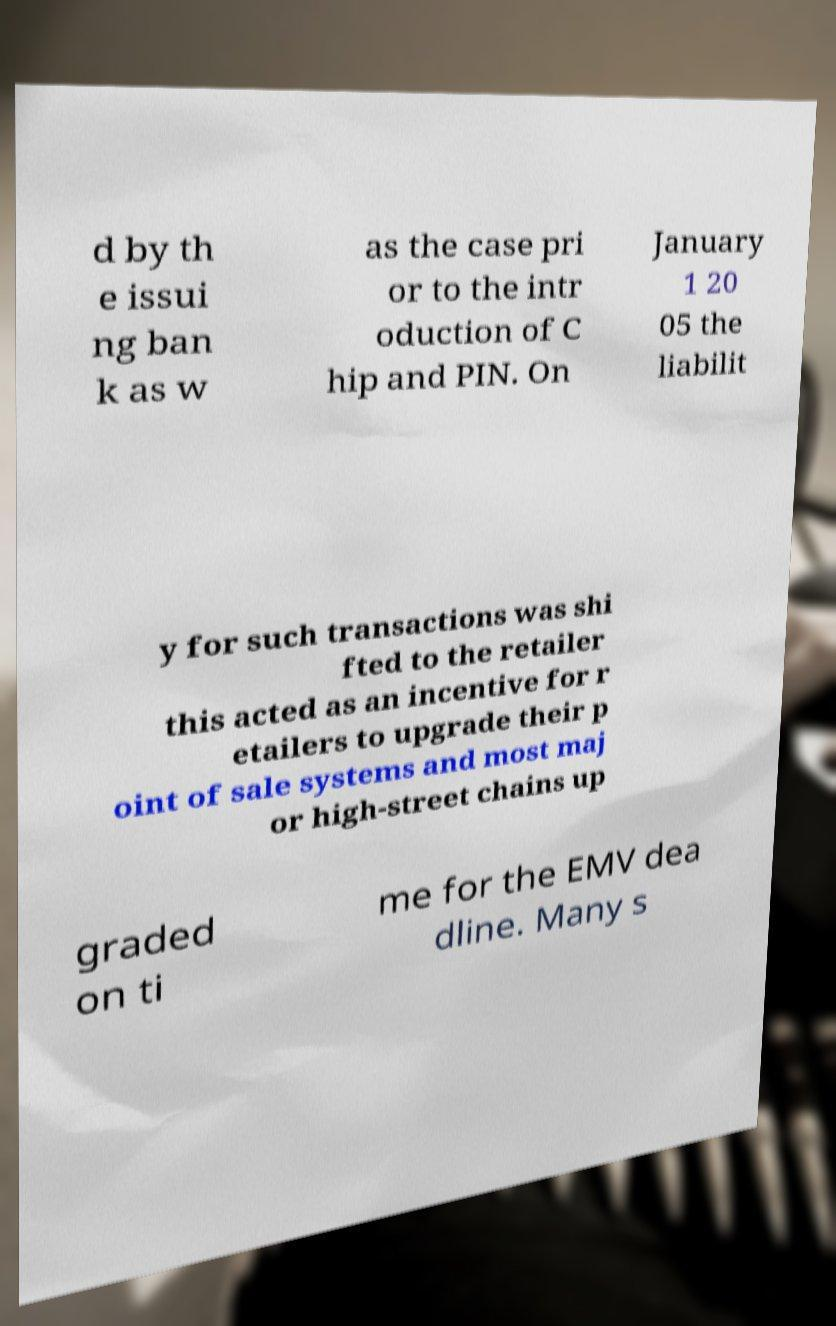What messages or text are displayed in this image? I need them in a readable, typed format. d by th e issui ng ban k as w as the case pri or to the intr oduction of C hip and PIN. On January 1 20 05 the liabilit y for such transactions was shi fted to the retailer this acted as an incentive for r etailers to upgrade their p oint of sale systems and most maj or high-street chains up graded on ti me for the EMV dea dline. Many s 